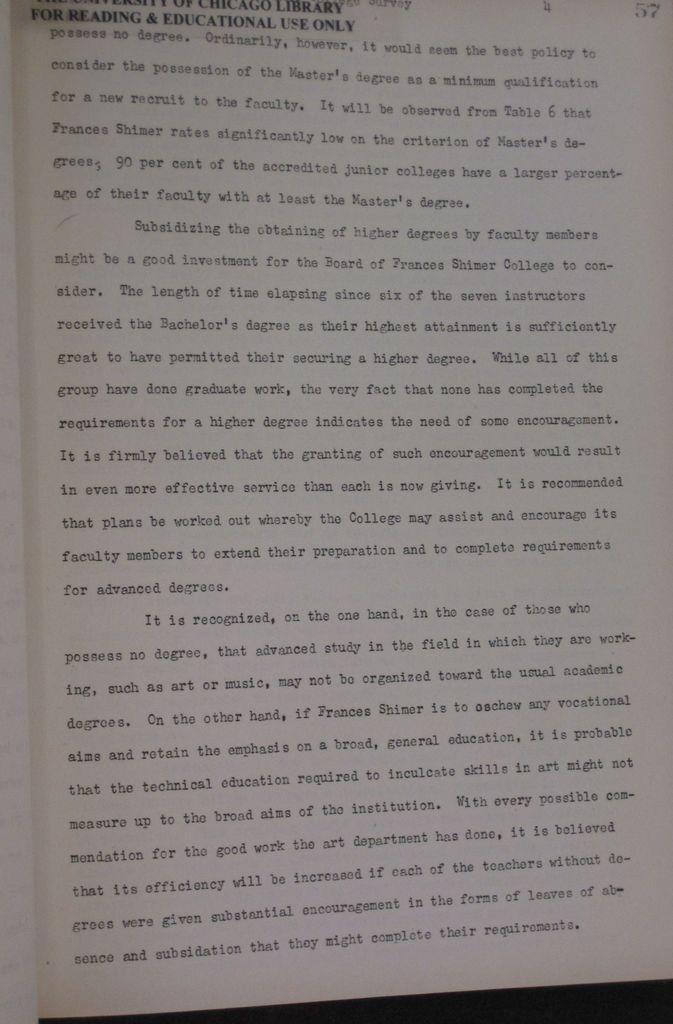<image>
Share a concise interpretation of the image provided. A book that is for reading and educational use only is open to page 57 